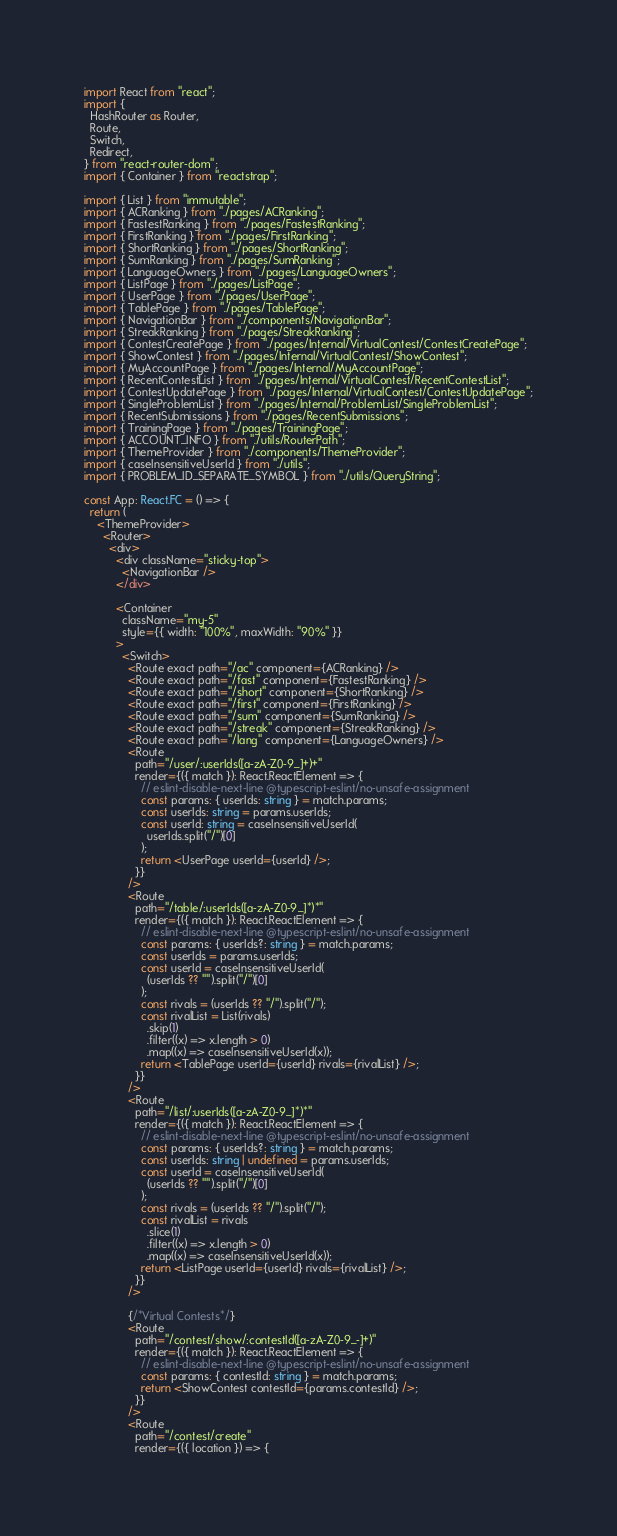Convert code to text. <code><loc_0><loc_0><loc_500><loc_500><_TypeScript_>import React from "react";
import {
  HashRouter as Router,
  Route,
  Switch,
  Redirect,
} from "react-router-dom";
import { Container } from "reactstrap";

import { List } from "immutable";
import { ACRanking } from "./pages/ACRanking";
import { FastestRanking } from "./pages/FastestRanking";
import { FirstRanking } from "./pages/FirstRanking";
import { ShortRanking } from "./pages/ShortRanking";
import { SumRanking } from "./pages/SumRanking";
import { LanguageOwners } from "./pages/LanguageOwners";
import { ListPage } from "./pages/ListPage";
import { UserPage } from "./pages/UserPage";
import { TablePage } from "./pages/TablePage";
import { NavigationBar } from "./components/NavigationBar";
import { StreakRanking } from "./pages/StreakRanking";
import { ContestCreatePage } from "./pages/Internal/VirtualContest/ContestCreatePage";
import { ShowContest } from "./pages/Internal/VirtualContest/ShowContest";
import { MyAccountPage } from "./pages/Internal/MyAccountPage";
import { RecentContestList } from "./pages/Internal/VirtualContest/RecentContestList";
import { ContestUpdatePage } from "./pages/Internal/VirtualContest/ContestUpdatePage";
import { SingleProblemList } from "./pages/Internal/ProblemList/SingleProblemList";
import { RecentSubmissions } from "./pages/RecentSubmissions";
import { TrainingPage } from "./pages/TrainingPage";
import { ACCOUNT_INFO } from "./utils/RouterPath";
import { ThemeProvider } from "./components/ThemeProvider";
import { caseInsensitiveUserId } from "./utils";
import { PROBLEM_ID_SEPARATE_SYMBOL } from "./utils/QueryString";

const App: React.FC = () => {
  return (
    <ThemeProvider>
      <Router>
        <div>
          <div className="sticky-top">
            <NavigationBar />
          </div>

          <Container
            className="my-5"
            style={{ width: "100%", maxWidth: "90%" }}
          >
            <Switch>
              <Route exact path="/ac" component={ACRanking} />
              <Route exact path="/fast" component={FastestRanking} />
              <Route exact path="/short" component={ShortRanking} />
              <Route exact path="/first" component={FirstRanking} />
              <Route exact path="/sum" component={SumRanking} />
              <Route exact path="/streak" component={StreakRanking} />
              <Route exact path="/lang" component={LanguageOwners} />
              <Route
                path="/user/:userIds([a-zA-Z0-9_]+)+"
                render={({ match }): React.ReactElement => {
                  // eslint-disable-next-line @typescript-eslint/no-unsafe-assignment
                  const params: { userIds: string } = match.params;
                  const userIds: string = params.userIds;
                  const userId: string = caseInsensitiveUserId(
                    userIds.split("/")[0]
                  );
                  return <UserPage userId={userId} />;
                }}
              />
              <Route
                path="/table/:userIds([a-zA-Z0-9_]*)*"
                render={({ match }): React.ReactElement => {
                  // eslint-disable-next-line @typescript-eslint/no-unsafe-assignment
                  const params: { userIds?: string } = match.params;
                  const userIds = params.userIds;
                  const userId = caseInsensitiveUserId(
                    (userIds ?? "").split("/")[0]
                  );
                  const rivals = (userIds ?? "/").split("/");
                  const rivalList = List(rivals)
                    .skip(1)
                    .filter((x) => x.length > 0)
                    .map((x) => caseInsensitiveUserId(x));
                  return <TablePage userId={userId} rivals={rivalList} />;
                }}
              />
              <Route
                path="/list/:userIds([a-zA-Z0-9_]*)*"
                render={({ match }): React.ReactElement => {
                  // eslint-disable-next-line @typescript-eslint/no-unsafe-assignment
                  const params: { userIds?: string } = match.params;
                  const userIds: string | undefined = params.userIds;
                  const userId = caseInsensitiveUserId(
                    (userIds ?? "").split("/")[0]
                  );
                  const rivals = (userIds ?? "/").split("/");
                  const rivalList = rivals
                    .slice(1)
                    .filter((x) => x.length > 0)
                    .map((x) => caseInsensitiveUserId(x));
                  return <ListPage userId={userId} rivals={rivalList} />;
                }}
              />

              {/*Virtual Contests*/}
              <Route
                path="/contest/show/:contestId([a-zA-Z0-9_-]+)"
                render={({ match }): React.ReactElement => {
                  // eslint-disable-next-line @typescript-eslint/no-unsafe-assignment
                  const params: { contestId: string } = match.params;
                  return <ShowContest contestId={params.contestId} />;
                }}
              />
              <Route
                path="/contest/create"
                render={({ location }) => {</code> 